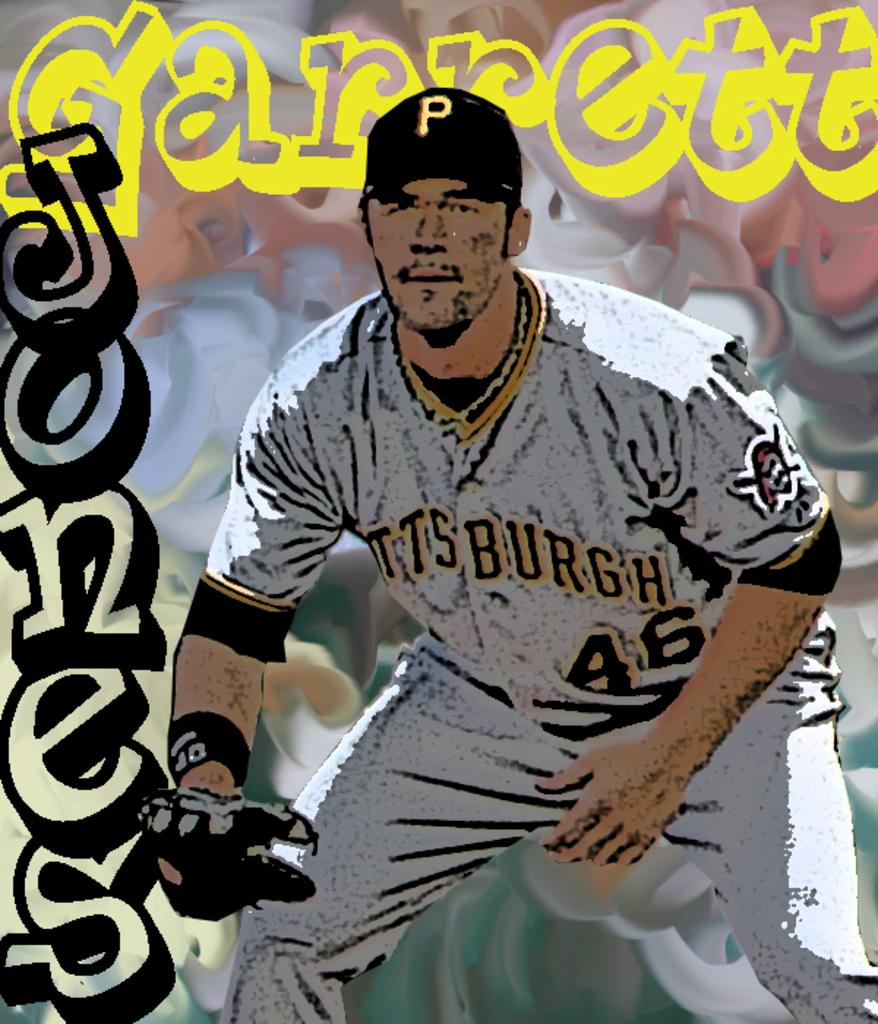What number is garret jones?
Make the answer very short. 46. Is jones still on the pirates team?
Make the answer very short. Yes. 